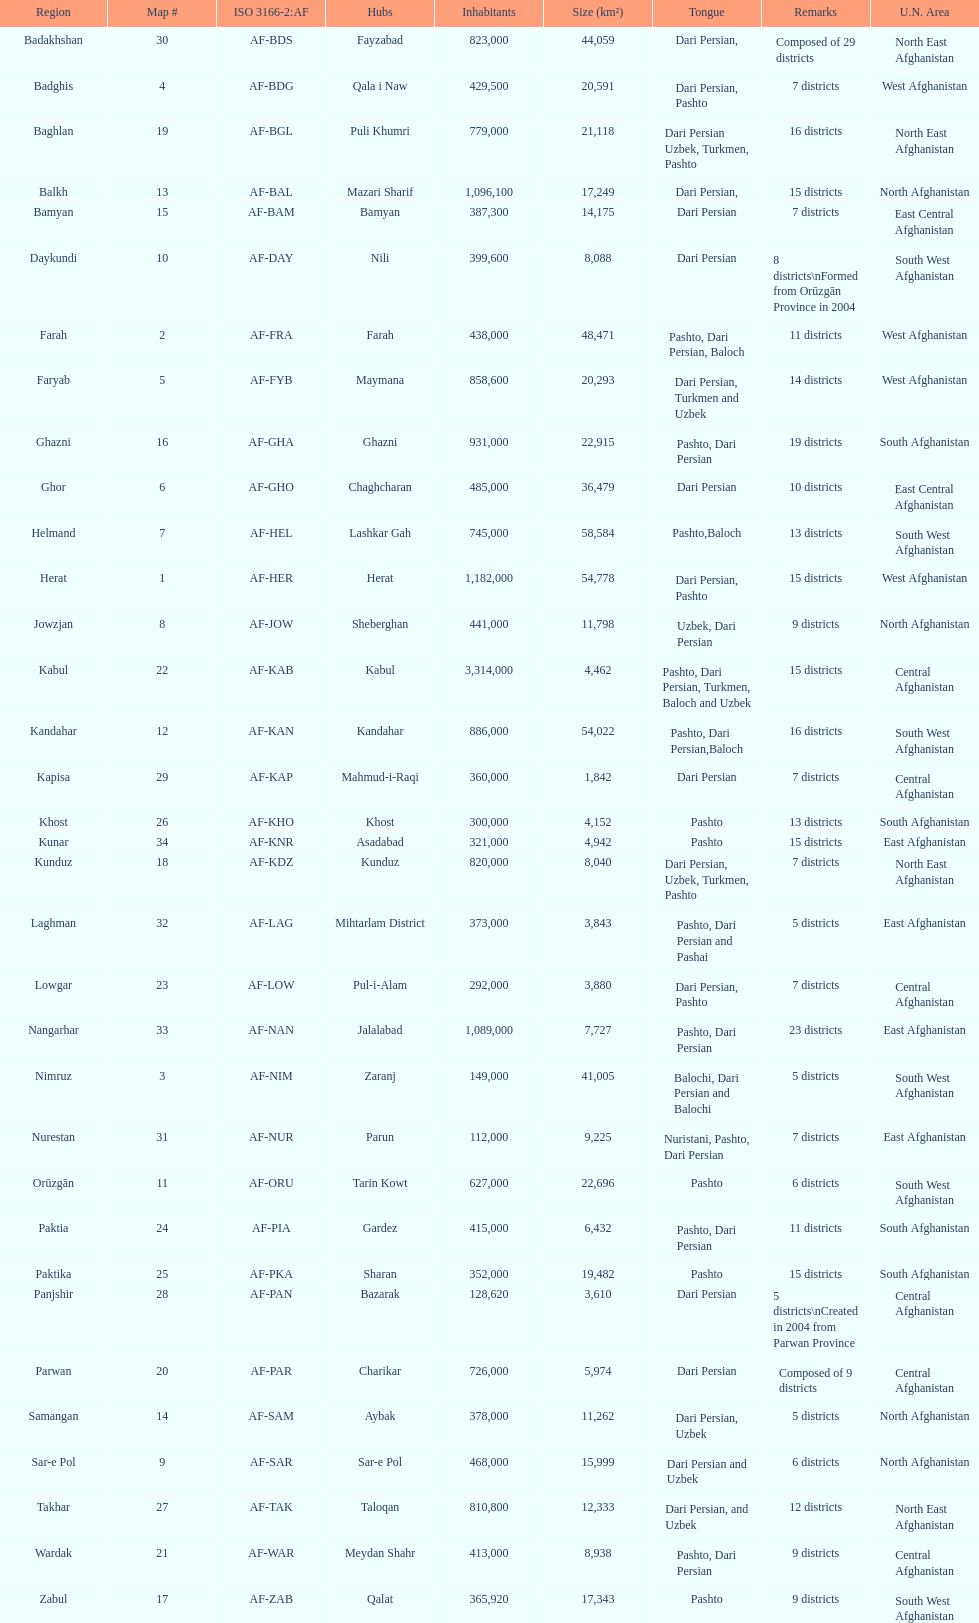How many districts are in the province of kunduz? 7. 